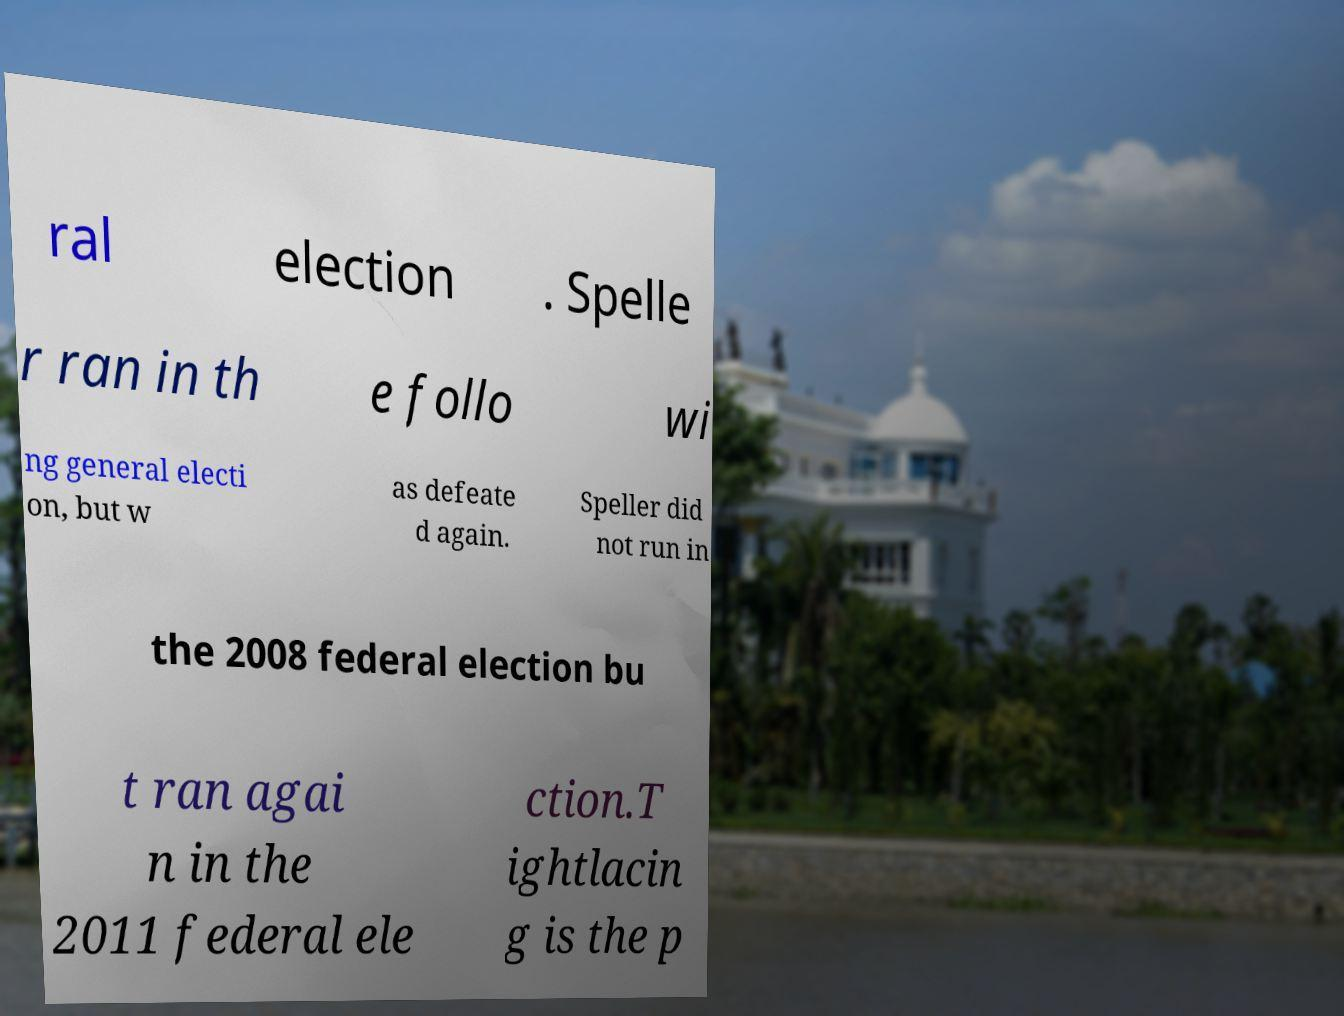For documentation purposes, I need the text within this image transcribed. Could you provide that? ral election . Spelle r ran in th e follo wi ng general electi on, but w as defeate d again. Speller did not run in the 2008 federal election bu t ran agai n in the 2011 federal ele ction.T ightlacin g is the p 